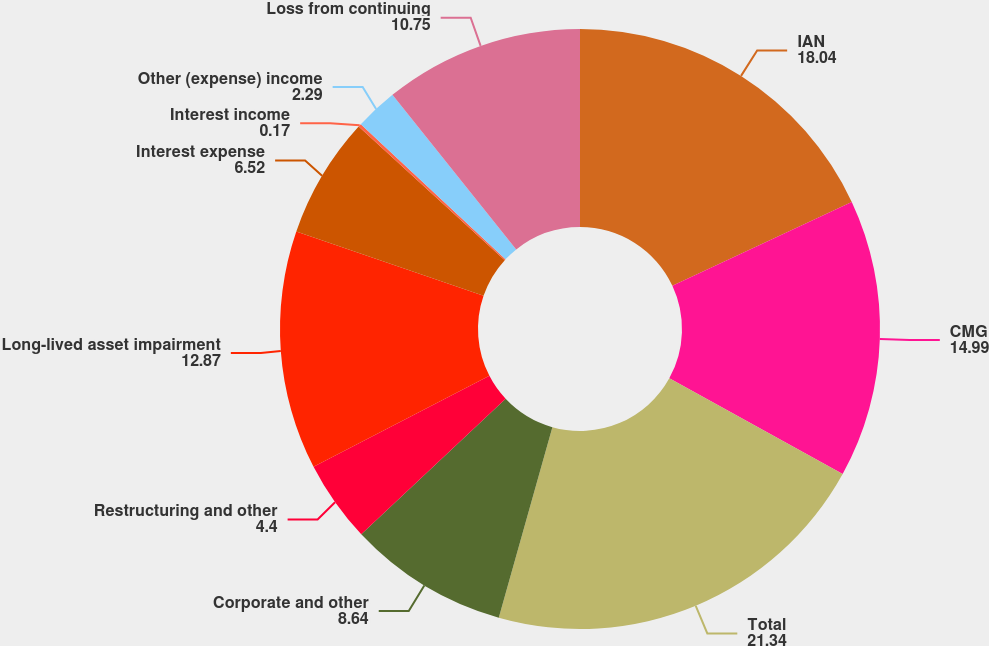Convert chart. <chart><loc_0><loc_0><loc_500><loc_500><pie_chart><fcel>IAN<fcel>CMG<fcel>Total<fcel>Corporate and other<fcel>Restructuring and other<fcel>Long-lived asset impairment<fcel>Interest expense<fcel>Interest income<fcel>Other (expense) income<fcel>Loss from continuing<nl><fcel>18.04%<fcel>14.99%<fcel>21.34%<fcel>8.64%<fcel>4.4%<fcel>12.87%<fcel>6.52%<fcel>0.17%<fcel>2.29%<fcel>10.75%<nl></chart> 